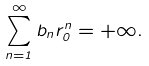<formula> <loc_0><loc_0><loc_500><loc_500>\sum _ { n = 1 } ^ { \infty } b _ { n } r _ { 0 } ^ { n } = + \infty .</formula> 